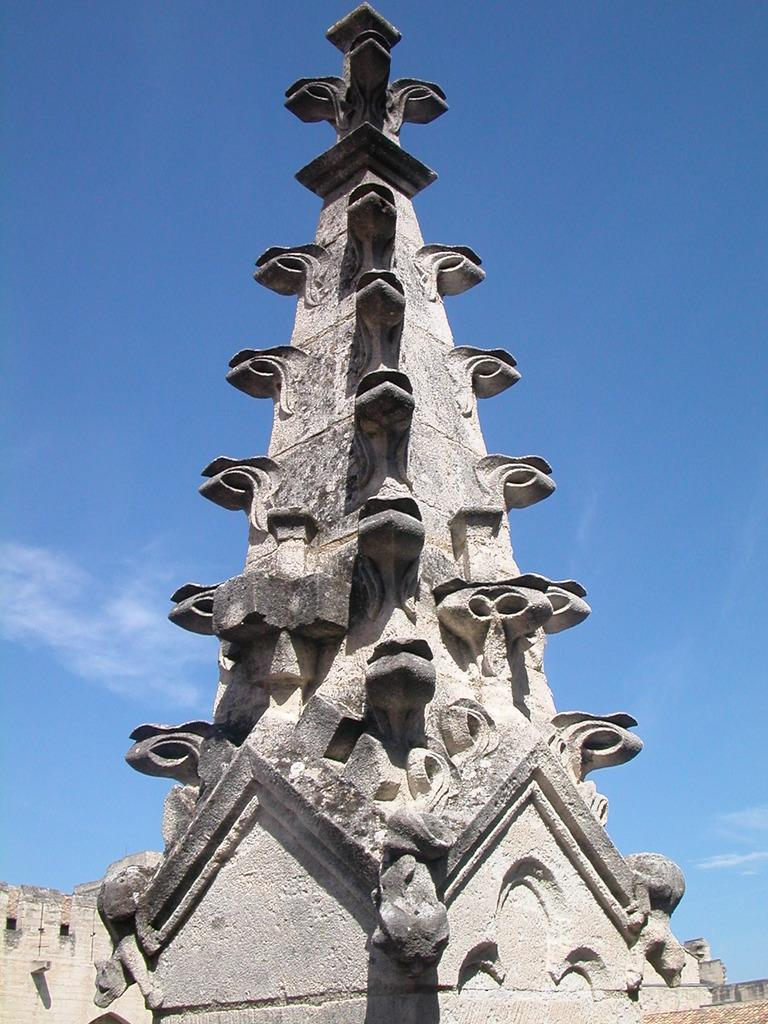What type of structure can be seen in the image? There is an architectural pillar in the image. What material was used to build the pillar? The pillar is built with stones. What can be seen in the background of the image? The sky is visible in the image. What type of leather is being polished in the image? There is no leather or polishing activity present in the image. 